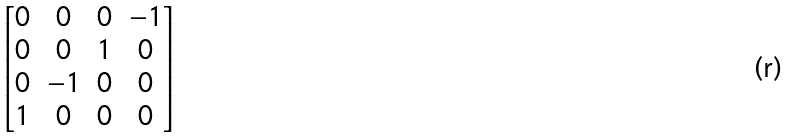<formula> <loc_0><loc_0><loc_500><loc_500>\begin{bmatrix} 0 & 0 & 0 & - 1 \\ 0 & 0 & 1 & 0 \\ 0 & - 1 & 0 & 0 \\ 1 & 0 & 0 & 0 \end{bmatrix}</formula> 